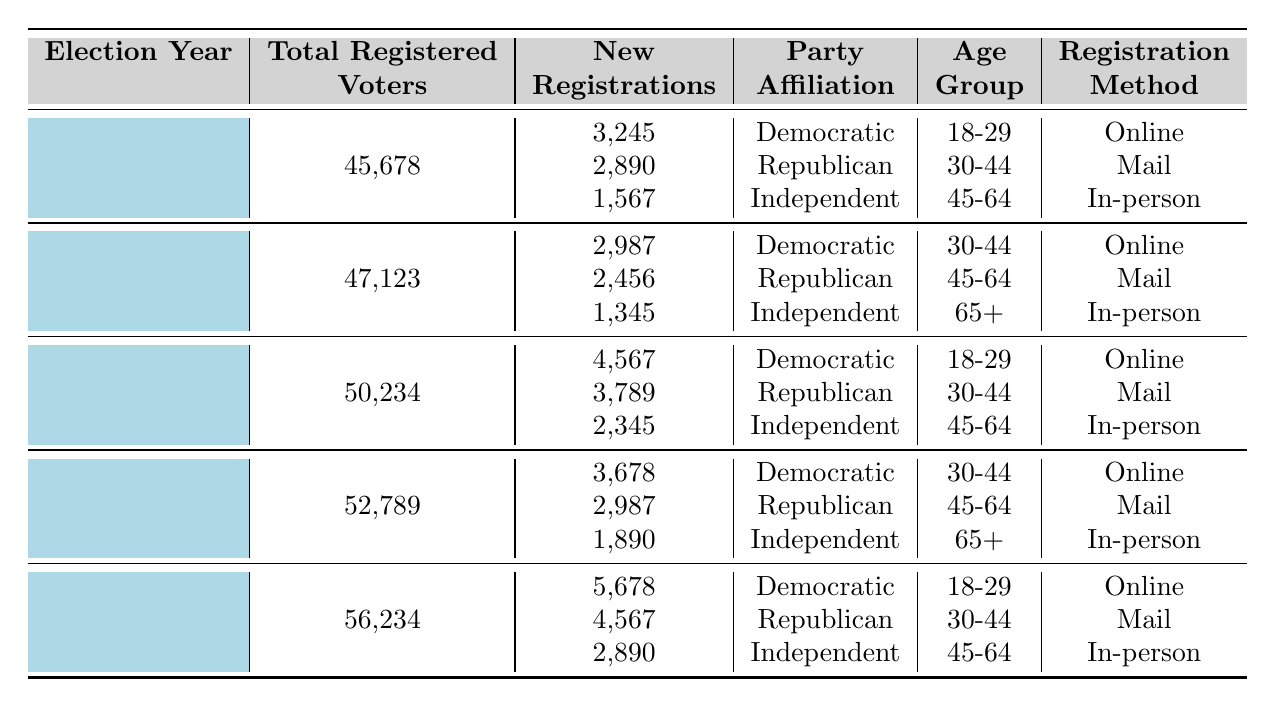What was the total number of registered voters in the 2016 election? In the 2016 row of the table, the total number of registered voters is directly stated as 50,234.
Answer: 50,234 How many new registrations were there for the Republican party in 2018? Looking at the 2018 row, the number of new registrations for the Republican party is 2,987, as indicated in the corresponding column.
Answer: 2,987 Which age group had the highest number of new registrations in 2020? In the 2020 row, the Democratic party had 5,678 new registrations for the 18-29 age group, the Republican party had 4,567 for the 30-44 age group, and the Independent party had 2,890 for the 45-64 age group. The Democratic party's 5,678 is the highest.
Answer: 18-29 What is the average number of new registrations across all parties in 2014? The total new registrations in 2014 can be calculated by summing the values: 2,987 (Democratic) + 2,456 (Republican) + 1,345 (Independent) = 6,788. Since there are 3 parties, the average is 6,788 / 3 = 2,262.67.
Answer: 2,262.67 Was there an increase in total registered voters from 2012 to 2020? The total registered voters in 2012 was 45,678 and in 2020 it was 56,234. Since 56,234 is greater than 45,678, there was indeed an increase.
Answer: Yes How many new Republican registrations were there in the last two election cycles combined? The Republican registrations for 2018 and 2020 are 2,987 and 4,567 respectively. Adding these gives 2,987 + 4,567 = 7,554.
Answer: 7,554 What was the total sum of new registrations for the Independent party in all election years? The new registrations for Independent are: 1,567 (2012) + 1,345 (2014) + 2,345 (2016) + 1,890 (2018) + 2,890 (2020). Summing these gives 1,567 + 1,345 + 2,345 + 1,890 + 2,890 = 11,037.
Answer: 11,037 For which election year did Democratic registrations peak in the 18-29 age group? The table shows Democratic registrations for the 18-29 age group were 3,245 in 2012 and 5,678 in 2016; thus, Democratic registrations peaked in 2016.
Answer: 2016 What is the percentage of new registrations for Democrats in 2018 compared to the total registered voters that year? In 2018, Democrats had 3,678 new registrations, and there were 52,789 total registered voters. The percentage is (3,678 / 52,789) * 100 ≈ 6.95%.
Answer: 6.95% 